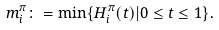<formula> <loc_0><loc_0><loc_500><loc_500>m ^ { \pi } _ { i } \colon = \min \{ H ^ { \pi } _ { i } ( t ) | 0 \leq t \leq 1 \} .</formula> 